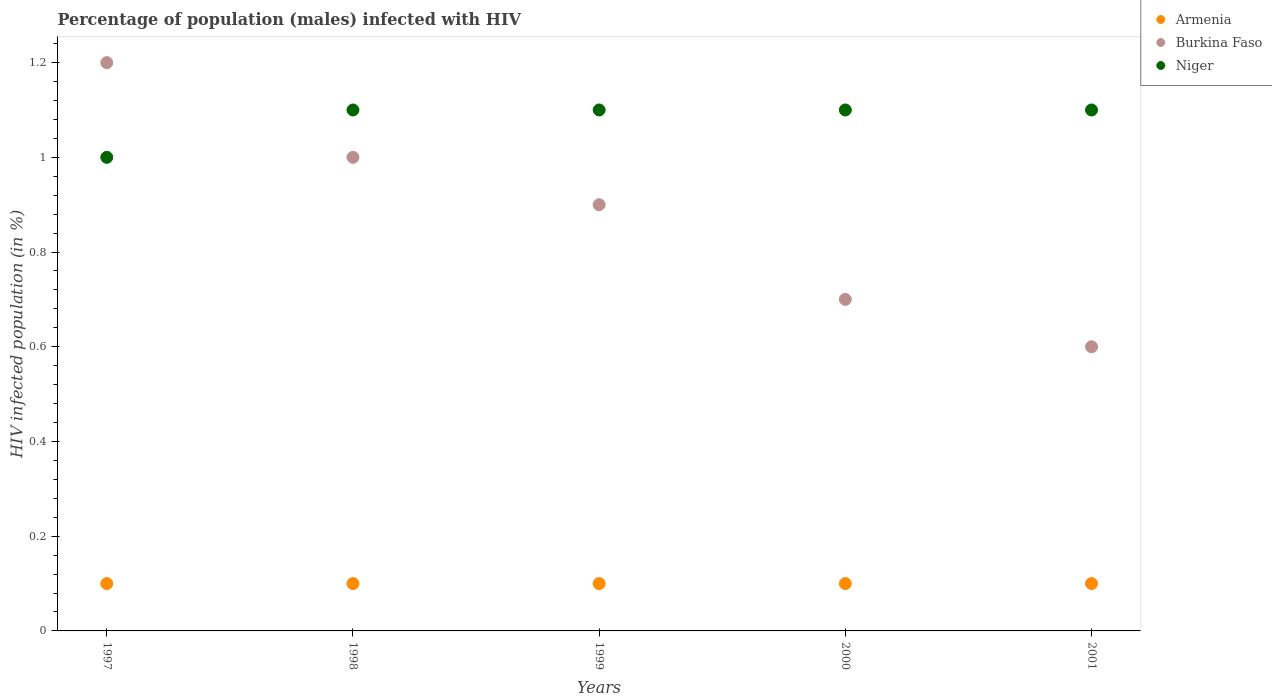How many different coloured dotlines are there?
Offer a terse response. 3. Is the number of dotlines equal to the number of legend labels?
Ensure brevity in your answer.  Yes. Across all years, what is the maximum percentage of HIV infected male population in Niger?
Your response must be concise. 1.1. Across all years, what is the minimum percentage of HIV infected male population in Niger?
Provide a short and direct response. 1. What is the total percentage of HIV infected male population in Burkina Faso in the graph?
Provide a succinct answer. 4.4. What is the difference between the percentage of HIV infected male population in Armenia in 1998 and that in 1999?
Ensure brevity in your answer.  0. What is the difference between the percentage of HIV infected male population in Niger in 1998 and the percentage of HIV infected male population in Burkina Faso in 2000?
Give a very brief answer. 0.4. Is the percentage of HIV infected male population in Burkina Faso in 2000 less than that in 2001?
Make the answer very short. No. Is the difference between the percentage of HIV infected male population in Niger in 1997 and 2001 greater than the difference between the percentage of HIV infected male population in Armenia in 1997 and 2001?
Your answer should be very brief. No. What is the difference between the highest and the lowest percentage of HIV infected male population in Niger?
Give a very brief answer. 0.1. In how many years, is the percentage of HIV infected male population in Niger greater than the average percentage of HIV infected male population in Niger taken over all years?
Your answer should be very brief. 4. Is the sum of the percentage of HIV infected male population in Burkina Faso in 1997 and 2001 greater than the maximum percentage of HIV infected male population in Armenia across all years?
Ensure brevity in your answer.  Yes. Is it the case that in every year, the sum of the percentage of HIV infected male population in Niger and percentage of HIV infected male population in Burkina Faso  is greater than the percentage of HIV infected male population in Armenia?
Your response must be concise. Yes. Is the percentage of HIV infected male population in Armenia strictly greater than the percentage of HIV infected male population in Burkina Faso over the years?
Provide a short and direct response. No. Is the percentage of HIV infected male population in Burkina Faso strictly less than the percentage of HIV infected male population in Armenia over the years?
Your answer should be very brief. No. How many dotlines are there?
Provide a succinct answer. 3. What is the difference between two consecutive major ticks on the Y-axis?
Make the answer very short. 0.2. How are the legend labels stacked?
Your answer should be very brief. Vertical. What is the title of the graph?
Your answer should be compact. Percentage of population (males) infected with HIV. What is the label or title of the X-axis?
Offer a terse response. Years. What is the label or title of the Y-axis?
Make the answer very short. HIV infected population (in %). What is the HIV infected population (in %) of Armenia in 1997?
Your response must be concise. 0.1. What is the HIV infected population (in %) in Niger in 1997?
Offer a terse response. 1. What is the HIV infected population (in %) in Niger in 1998?
Ensure brevity in your answer.  1.1. What is the HIV infected population (in %) in Armenia in 1999?
Your response must be concise. 0.1. What is the HIV infected population (in %) in Burkina Faso in 1999?
Offer a terse response. 0.9. What is the HIV infected population (in %) in Armenia in 2000?
Provide a short and direct response. 0.1. What is the HIV infected population (in %) of Burkina Faso in 2000?
Keep it short and to the point. 0.7. What is the HIV infected population (in %) of Niger in 2000?
Your answer should be very brief. 1.1. What is the HIV infected population (in %) of Armenia in 2001?
Your answer should be very brief. 0.1. What is the HIV infected population (in %) in Burkina Faso in 2001?
Provide a succinct answer. 0.6. What is the HIV infected population (in %) of Niger in 2001?
Ensure brevity in your answer.  1.1. Across all years, what is the maximum HIV infected population (in %) of Armenia?
Offer a very short reply. 0.1. Across all years, what is the minimum HIV infected population (in %) in Burkina Faso?
Ensure brevity in your answer.  0.6. What is the total HIV infected population (in %) in Armenia in the graph?
Offer a very short reply. 0.5. What is the difference between the HIV infected population (in %) of Armenia in 1997 and that in 1998?
Ensure brevity in your answer.  0. What is the difference between the HIV infected population (in %) in Burkina Faso in 1997 and that in 1998?
Your answer should be compact. 0.2. What is the difference between the HIV infected population (in %) of Niger in 1997 and that in 1998?
Your answer should be compact. -0.1. What is the difference between the HIV infected population (in %) in Armenia in 1997 and that in 1999?
Your answer should be very brief. 0. What is the difference between the HIV infected population (in %) of Niger in 1997 and that in 2000?
Your answer should be compact. -0.1. What is the difference between the HIV infected population (in %) in Armenia in 1997 and that in 2001?
Give a very brief answer. 0. What is the difference between the HIV infected population (in %) of Burkina Faso in 1997 and that in 2001?
Ensure brevity in your answer.  0.6. What is the difference between the HIV infected population (in %) of Armenia in 1998 and that in 1999?
Provide a short and direct response. 0. What is the difference between the HIV infected population (in %) of Burkina Faso in 1998 and that in 1999?
Ensure brevity in your answer.  0.1. What is the difference between the HIV infected population (in %) of Niger in 1998 and that in 1999?
Give a very brief answer. 0. What is the difference between the HIV infected population (in %) of Niger in 1998 and that in 2000?
Offer a terse response. 0. What is the difference between the HIV infected population (in %) in Burkina Faso in 1998 and that in 2001?
Keep it short and to the point. 0.4. What is the difference between the HIV infected population (in %) in Burkina Faso in 1999 and that in 2000?
Your response must be concise. 0.2. What is the difference between the HIV infected population (in %) of Niger in 1999 and that in 2000?
Your answer should be compact. 0. What is the difference between the HIV infected population (in %) of Armenia in 1999 and that in 2001?
Provide a short and direct response. 0. What is the difference between the HIV infected population (in %) in Burkina Faso in 1999 and that in 2001?
Make the answer very short. 0.3. What is the difference between the HIV infected population (in %) of Niger in 1999 and that in 2001?
Keep it short and to the point. 0. What is the difference between the HIV infected population (in %) in Burkina Faso in 2000 and that in 2001?
Make the answer very short. 0.1. What is the difference between the HIV infected population (in %) of Niger in 2000 and that in 2001?
Give a very brief answer. 0. What is the difference between the HIV infected population (in %) of Armenia in 1997 and the HIV infected population (in %) of Burkina Faso in 1998?
Offer a very short reply. -0.9. What is the difference between the HIV infected population (in %) of Armenia in 1997 and the HIV infected population (in %) of Burkina Faso in 1999?
Give a very brief answer. -0.8. What is the difference between the HIV infected population (in %) of Burkina Faso in 1997 and the HIV infected population (in %) of Niger in 1999?
Your answer should be very brief. 0.1. What is the difference between the HIV infected population (in %) of Armenia in 1997 and the HIV infected population (in %) of Burkina Faso in 2000?
Your answer should be very brief. -0.6. What is the difference between the HIV infected population (in %) in Armenia in 1997 and the HIV infected population (in %) in Niger in 2000?
Make the answer very short. -1. What is the difference between the HIV infected population (in %) of Burkina Faso in 1997 and the HIV infected population (in %) of Niger in 2000?
Your answer should be very brief. 0.1. What is the difference between the HIV infected population (in %) in Armenia in 1997 and the HIV infected population (in %) in Burkina Faso in 2001?
Offer a terse response. -0.5. What is the difference between the HIV infected population (in %) of Armenia in 1997 and the HIV infected population (in %) of Niger in 2001?
Ensure brevity in your answer.  -1. What is the difference between the HIV infected population (in %) in Burkina Faso in 1998 and the HIV infected population (in %) in Niger in 1999?
Keep it short and to the point. -0.1. What is the difference between the HIV infected population (in %) in Armenia in 1998 and the HIV infected population (in %) in Burkina Faso in 2000?
Your answer should be compact. -0.6. What is the difference between the HIV infected population (in %) of Armenia in 1998 and the HIV infected population (in %) of Niger in 2000?
Offer a very short reply. -1. What is the difference between the HIV infected population (in %) of Burkina Faso in 1998 and the HIV infected population (in %) of Niger in 2000?
Offer a terse response. -0.1. What is the difference between the HIV infected population (in %) of Armenia in 1998 and the HIV infected population (in %) of Burkina Faso in 2001?
Your answer should be very brief. -0.5. What is the difference between the HIV infected population (in %) in Armenia in 1998 and the HIV infected population (in %) in Niger in 2001?
Make the answer very short. -1. What is the difference between the HIV infected population (in %) in Burkina Faso in 1998 and the HIV infected population (in %) in Niger in 2001?
Offer a terse response. -0.1. What is the difference between the HIV infected population (in %) in Armenia in 1999 and the HIV infected population (in %) in Burkina Faso in 2000?
Ensure brevity in your answer.  -0.6. What is the difference between the HIV infected population (in %) of Armenia in 1999 and the HIV infected population (in %) of Niger in 2000?
Your answer should be very brief. -1. What is the difference between the HIV infected population (in %) in Burkina Faso in 1999 and the HIV infected population (in %) in Niger in 2000?
Keep it short and to the point. -0.2. What is the difference between the HIV infected population (in %) in Armenia in 1999 and the HIV infected population (in %) in Niger in 2001?
Your answer should be compact. -1. What is the difference between the HIV infected population (in %) of Armenia in 2000 and the HIV infected population (in %) of Burkina Faso in 2001?
Offer a very short reply. -0.5. What is the difference between the HIV infected population (in %) of Burkina Faso in 2000 and the HIV infected population (in %) of Niger in 2001?
Your response must be concise. -0.4. What is the average HIV infected population (in %) of Burkina Faso per year?
Your answer should be very brief. 0.88. What is the average HIV infected population (in %) of Niger per year?
Keep it short and to the point. 1.08. In the year 1997, what is the difference between the HIV infected population (in %) of Armenia and HIV infected population (in %) of Niger?
Offer a very short reply. -0.9. In the year 1997, what is the difference between the HIV infected population (in %) in Burkina Faso and HIV infected population (in %) in Niger?
Your response must be concise. 0.2. In the year 1998, what is the difference between the HIV infected population (in %) in Burkina Faso and HIV infected population (in %) in Niger?
Ensure brevity in your answer.  -0.1. In the year 1999, what is the difference between the HIV infected population (in %) of Armenia and HIV infected population (in %) of Burkina Faso?
Give a very brief answer. -0.8. In the year 1999, what is the difference between the HIV infected population (in %) in Armenia and HIV infected population (in %) in Niger?
Your answer should be compact. -1. In the year 1999, what is the difference between the HIV infected population (in %) of Burkina Faso and HIV infected population (in %) of Niger?
Ensure brevity in your answer.  -0.2. In the year 2000, what is the difference between the HIV infected population (in %) in Armenia and HIV infected population (in %) in Burkina Faso?
Your response must be concise. -0.6. In the year 2000, what is the difference between the HIV infected population (in %) in Armenia and HIV infected population (in %) in Niger?
Offer a terse response. -1. In the year 2000, what is the difference between the HIV infected population (in %) in Burkina Faso and HIV infected population (in %) in Niger?
Give a very brief answer. -0.4. In the year 2001, what is the difference between the HIV infected population (in %) in Armenia and HIV infected population (in %) in Niger?
Ensure brevity in your answer.  -1. In the year 2001, what is the difference between the HIV infected population (in %) of Burkina Faso and HIV infected population (in %) of Niger?
Offer a terse response. -0.5. What is the ratio of the HIV infected population (in %) of Burkina Faso in 1997 to that in 1998?
Ensure brevity in your answer.  1.2. What is the ratio of the HIV infected population (in %) of Niger in 1997 to that in 1998?
Provide a succinct answer. 0.91. What is the ratio of the HIV infected population (in %) in Armenia in 1997 to that in 1999?
Keep it short and to the point. 1. What is the ratio of the HIV infected population (in %) in Burkina Faso in 1997 to that in 1999?
Your answer should be compact. 1.33. What is the ratio of the HIV infected population (in %) of Niger in 1997 to that in 1999?
Provide a succinct answer. 0.91. What is the ratio of the HIV infected population (in %) of Armenia in 1997 to that in 2000?
Keep it short and to the point. 1. What is the ratio of the HIV infected population (in %) of Burkina Faso in 1997 to that in 2000?
Keep it short and to the point. 1.71. What is the ratio of the HIV infected population (in %) of Niger in 1997 to that in 2001?
Provide a short and direct response. 0.91. What is the ratio of the HIV infected population (in %) in Armenia in 1998 to that in 1999?
Your answer should be compact. 1. What is the ratio of the HIV infected population (in %) in Burkina Faso in 1998 to that in 1999?
Offer a terse response. 1.11. What is the ratio of the HIV infected population (in %) of Armenia in 1998 to that in 2000?
Your answer should be very brief. 1. What is the ratio of the HIV infected population (in %) in Burkina Faso in 1998 to that in 2000?
Your answer should be compact. 1.43. What is the ratio of the HIV infected population (in %) of Niger in 1998 to that in 2000?
Your answer should be compact. 1. What is the ratio of the HIV infected population (in %) of Armenia in 1999 to that in 2000?
Provide a succinct answer. 1. What is the ratio of the HIV infected population (in %) of Armenia in 1999 to that in 2001?
Offer a terse response. 1. What is the ratio of the HIV infected population (in %) of Burkina Faso in 1999 to that in 2001?
Offer a terse response. 1.5. What is the ratio of the HIV infected population (in %) in Armenia in 2000 to that in 2001?
Ensure brevity in your answer.  1. What is the ratio of the HIV infected population (in %) of Burkina Faso in 2000 to that in 2001?
Offer a terse response. 1.17. What is the difference between the highest and the second highest HIV infected population (in %) of Armenia?
Ensure brevity in your answer.  0. What is the difference between the highest and the second highest HIV infected population (in %) in Burkina Faso?
Give a very brief answer. 0.2. What is the difference between the highest and the second highest HIV infected population (in %) in Niger?
Make the answer very short. 0. What is the difference between the highest and the lowest HIV infected population (in %) of Burkina Faso?
Offer a very short reply. 0.6. 